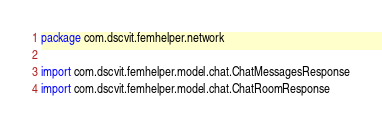<code> <loc_0><loc_0><loc_500><loc_500><_Kotlin_>package com.dscvit.femhelper.network

import com.dscvit.femhelper.model.chat.ChatMessagesResponse
import com.dscvit.femhelper.model.chat.ChatRoomResponse</code> 